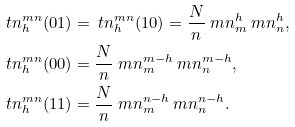Convert formula to latex. <formula><loc_0><loc_0><loc_500><loc_500>\ t n ^ { m n } _ { h } ( 0 1 ) & = \ t n ^ { m n } _ { h } ( 1 0 ) = \frac { N } { n } \ m n ^ { h } _ { m } \ m n ^ { h } _ { n } , \\ \ t n ^ { m n } _ { h } ( 0 0 ) & = \frac { N } { n } \ m n ^ { m - h } _ { m } \ m n ^ { m - h } _ { n } , \\ \ t n ^ { m n } _ { h } ( 1 1 ) & = \frac { N } { n } \ m n ^ { n - h } _ { m } \ m n ^ { n - h } _ { n } .</formula> 